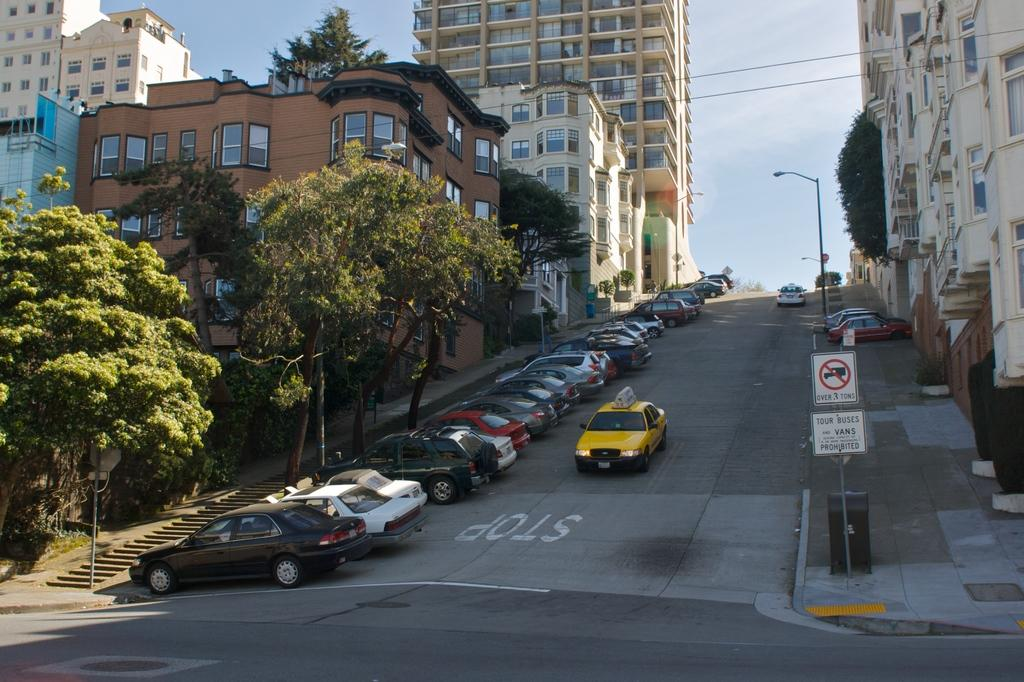<image>
Relay a brief, clear account of the picture shown. The taxi is driving down to a stop on the road. 